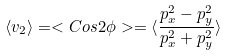Convert formula to latex. <formula><loc_0><loc_0><loc_500><loc_500>\langle v _ { 2 } \rangle = < C o s 2 \phi > = \langle \frac { p _ { x } ^ { 2 } - p _ { y } ^ { 2 } } { p _ { x } ^ { 2 } + p _ { y } ^ { 2 } } \rangle</formula> 